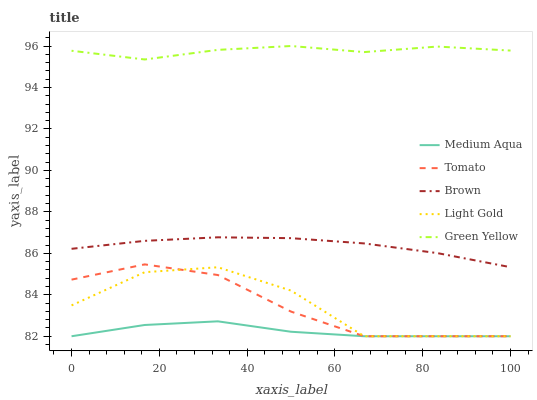Does Medium Aqua have the minimum area under the curve?
Answer yes or no. Yes. Does Green Yellow have the maximum area under the curve?
Answer yes or no. Yes. Does Brown have the minimum area under the curve?
Answer yes or no. No. Does Brown have the maximum area under the curve?
Answer yes or no. No. Is Brown the smoothest?
Answer yes or no. Yes. Is Light Gold the roughest?
Answer yes or no. Yes. Is Green Yellow the smoothest?
Answer yes or no. No. Is Green Yellow the roughest?
Answer yes or no. No. Does Tomato have the lowest value?
Answer yes or no. Yes. Does Brown have the lowest value?
Answer yes or no. No. Does Green Yellow have the highest value?
Answer yes or no. Yes. Does Brown have the highest value?
Answer yes or no. No. Is Tomato less than Green Yellow?
Answer yes or no. Yes. Is Green Yellow greater than Light Gold?
Answer yes or no. Yes. Does Medium Aqua intersect Tomato?
Answer yes or no. Yes. Is Medium Aqua less than Tomato?
Answer yes or no. No. Is Medium Aqua greater than Tomato?
Answer yes or no. No. Does Tomato intersect Green Yellow?
Answer yes or no. No. 